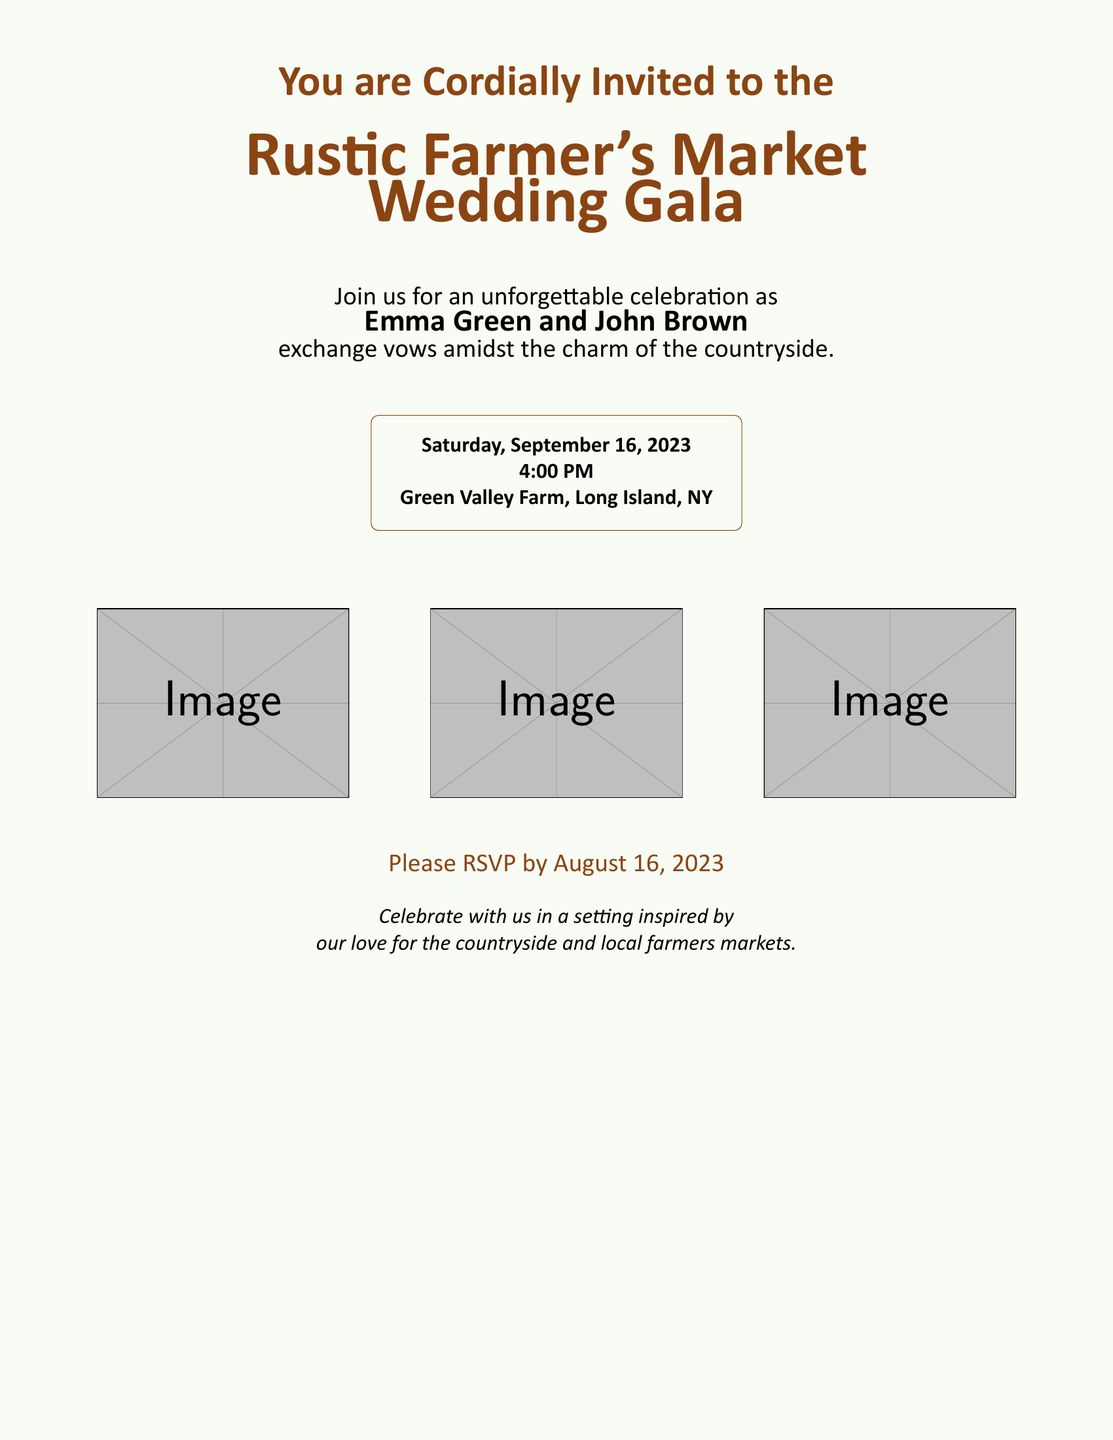What is the couple's names? The names of the couple getting married are mentioned in the invitation.
Answer: Emma Green and John Brown When is the wedding date? The date of the wedding is specified in the invitation.
Answer: Saturday, September 16, 2023 What time does the ceremony start? The start time of the wedding ceremony is noted in the document.
Answer: 4:00 PM Where is the wedding venue? The location of the wedding is indicated in the invitation details.
Answer: Green Valley Farm, Long Island, NY What is the RSVP deadline? The document provides a specific date by which guests should respond.
Answer: August 16, 2023 What theme does the invitation reflect? The invitation's design and illustrations point to a particular theme.
Answer: Rustic Farmer's Market What color is the invitation predominantly using? The main color used in the invitation's text is identified.
Answer: Rustic brown What does the invitation celebrate? The invitation outlines the purpose of the gathering.
Answer: The couple's love for the countryside and local farmers markets How many images are included in the invitation? The number of images presented in the layout of the invitation is stated.
Answer: Three images 